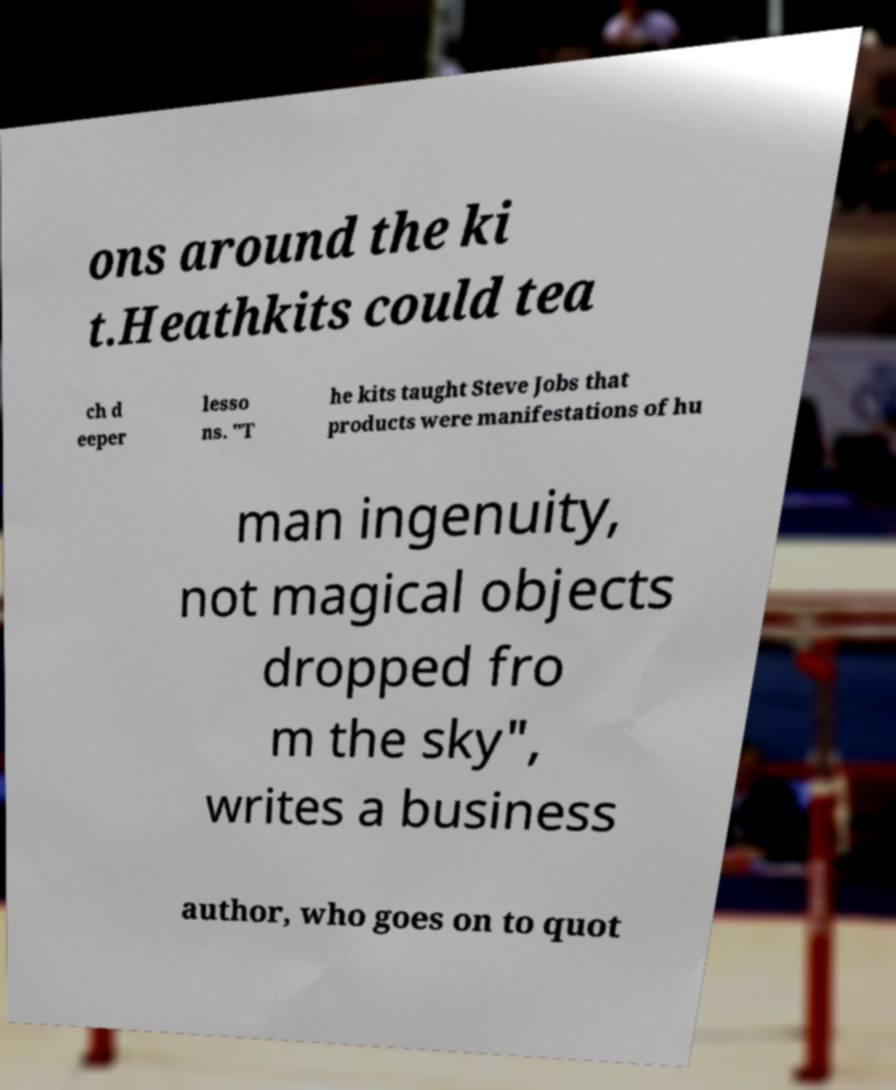Can you read and provide the text displayed in the image?This photo seems to have some interesting text. Can you extract and type it out for me? ons around the ki t.Heathkits could tea ch d eeper lesso ns. "T he kits taught Steve Jobs that products were manifestations of hu man ingenuity, not magical objects dropped fro m the sky", writes a business author, who goes on to quot 